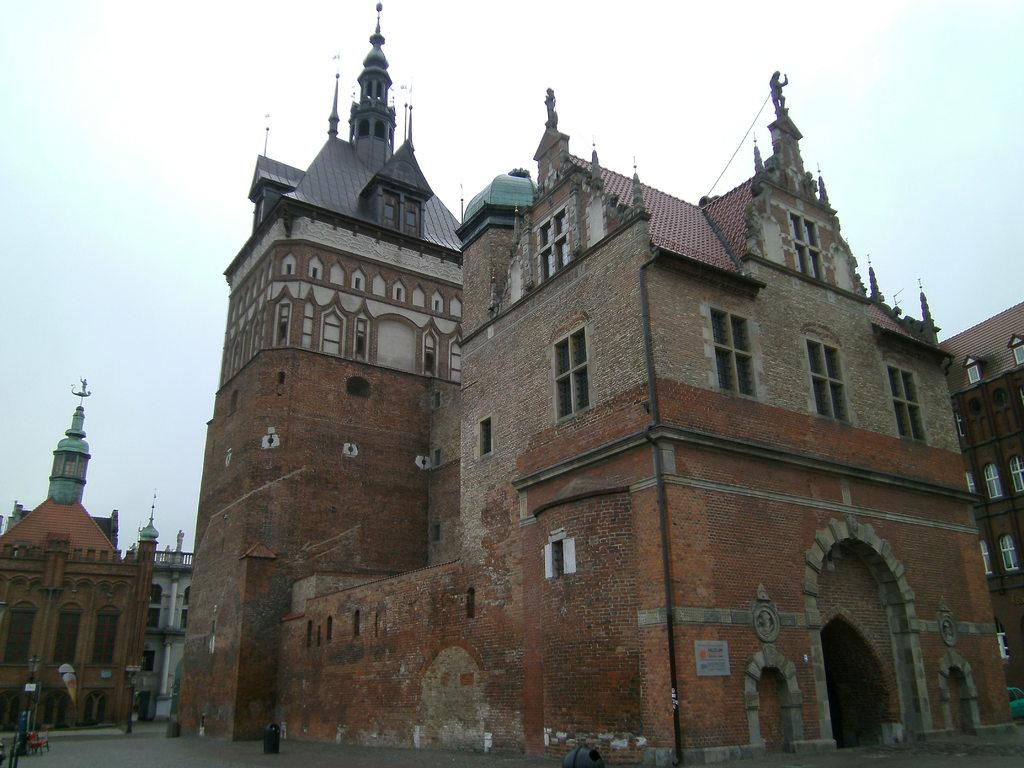What type of structures can be seen in the image? A: There are buildings in the image. What material are the buildings made of? The buildings are made up of red bricks. What is located on the ground near the buildings? There is a dustbin on the ground. What is the condition of the sky in the image? The sky is clear in the image. What type of plant is shown falling from the sky in the image? There is no plant falling from the sky in the image; the sky is clear. 